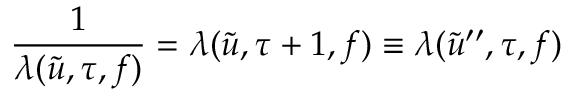<formula> <loc_0><loc_0><loc_500><loc_500>\frac { 1 } { \lambda ( \tilde { u } , \tau , f ) } = \lambda ( \tilde { u } , \tau + 1 , f ) \equiv \lambda ( \tilde { u } ^ { \prime \prime } , \tau , f )</formula> 